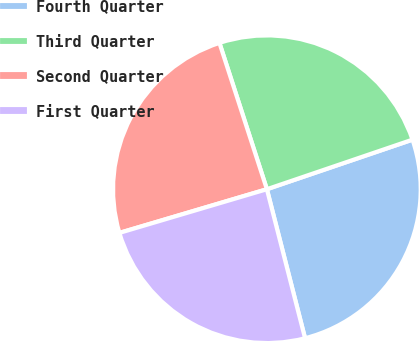Convert chart to OTSL. <chart><loc_0><loc_0><loc_500><loc_500><pie_chart><fcel>Fourth Quarter<fcel>Third Quarter<fcel>Second Quarter<fcel>First Quarter<nl><fcel>26.23%<fcel>24.77%<fcel>24.59%<fcel>24.41%<nl></chart> 